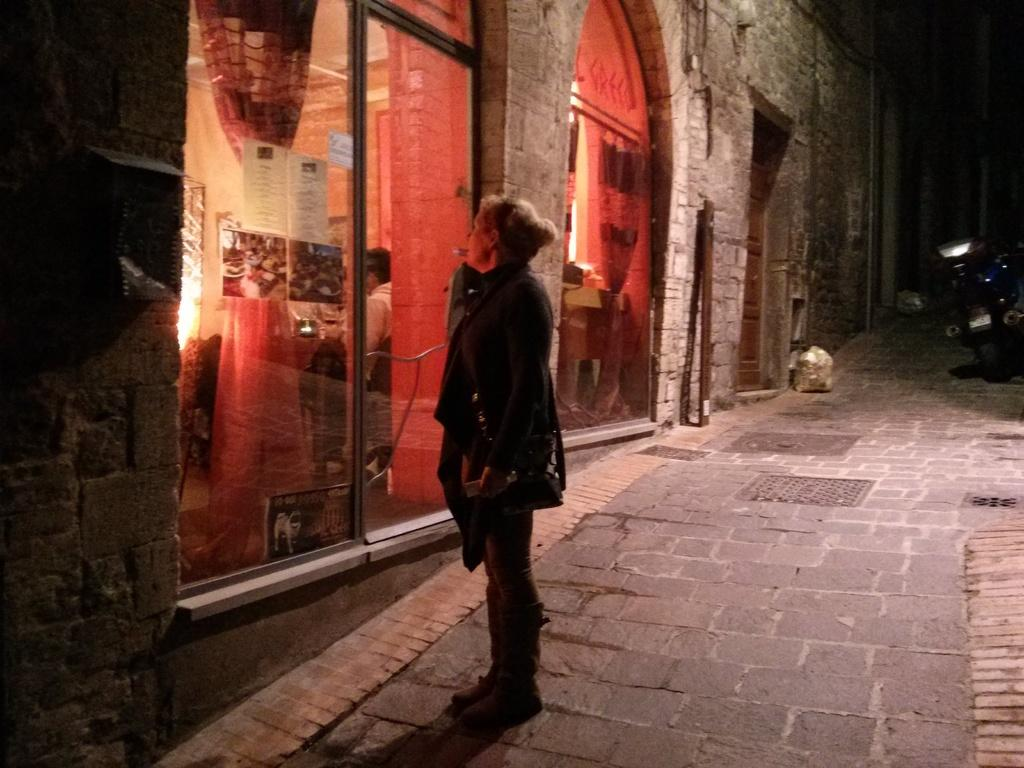What is the woman doing in the image? The woman is standing on a pavement. What can be seen in the background of the image? There is a building in the background. What feature of the building is mentioned in the facts? The building has glass doors. What else is present on the pavement besides the woman? There is a bike on the pavement. What degree does the woman have in the image? There is no information about the woman's degree in the image. 